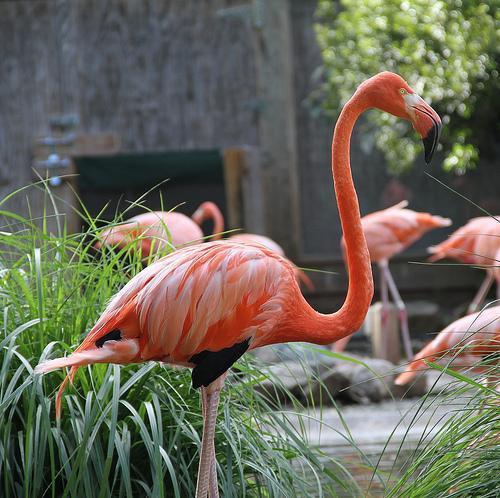How many feet are on the ground?
Give a very brief answer. 2. 